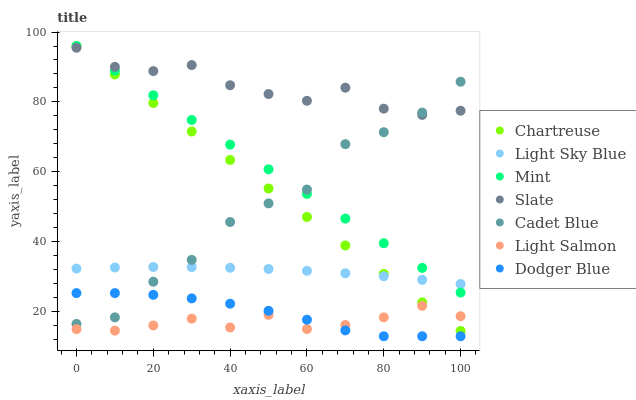Does Light Salmon have the minimum area under the curve?
Answer yes or no. Yes. Does Slate have the maximum area under the curve?
Answer yes or no. Yes. Does Cadet Blue have the minimum area under the curve?
Answer yes or no. No. Does Cadet Blue have the maximum area under the curve?
Answer yes or no. No. Is Mint the smoothest?
Answer yes or no. Yes. Is Cadet Blue the roughest?
Answer yes or no. Yes. Is Slate the smoothest?
Answer yes or no. No. Is Slate the roughest?
Answer yes or no. No. Does Dodger Blue have the lowest value?
Answer yes or no. Yes. Does Cadet Blue have the lowest value?
Answer yes or no. No. Does Mint have the highest value?
Answer yes or no. Yes. Does Cadet Blue have the highest value?
Answer yes or no. No. Is Light Sky Blue less than Slate?
Answer yes or no. Yes. Is Light Sky Blue greater than Dodger Blue?
Answer yes or no. Yes. Does Dodger Blue intersect Cadet Blue?
Answer yes or no. Yes. Is Dodger Blue less than Cadet Blue?
Answer yes or no. No. Is Dodger Blue greater than Cadet Blue?
Answer yes or no. No. Does Light Sky Blue intersect Slate?
Answer yes or no. No. 